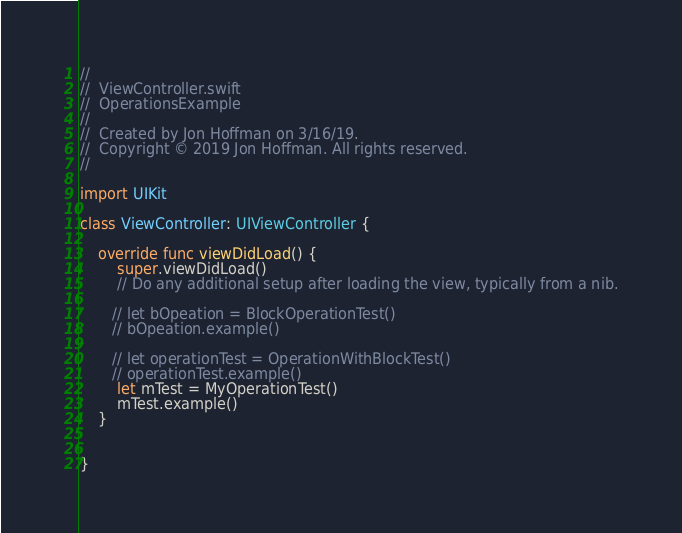<code> <loc_0><loc_0><loc_500><loc_500><_Swift_>//
//  ViewController.swift
//  OperationsExample
//
//  Created by Jon Hoffman on 3/16/19.
//  Copyright © 2019 Jon Hoffman. All rights reserved.
//

import UIKit

class ViewController: UIViewController {

    override func viewDidLoad() {
        super.viewDidLoad()
        // Do any additional setup after loading the view, typically from a nib.
        
       // let bOpeation = BlockOperationTest()
       // bOpeation.example()
        
       // let operationTest = OperationWithBlockTest()
       // operationTest.example()
        let mTest = MyOperationTest()
        mTest.example()
    }


}

</code> 